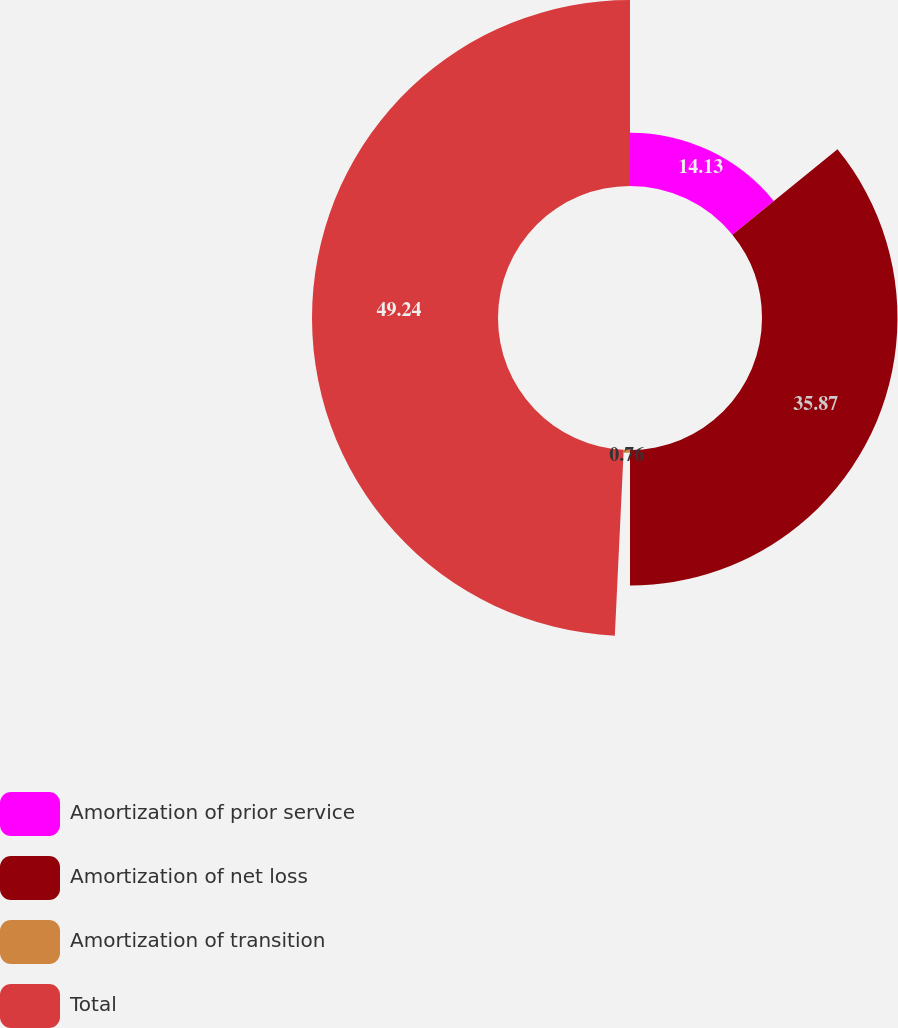Convert chart to OTSL. <chart><loc_0><loc_0><loc_500><loc_500><pie_chart><fcel>Amortization of prior service<fcel>Amortization of net loss<fcel>Amortization of transition<fcel>Total<nl><fcel>14.13%<fcel>35.87%<fcel>0.76%<fcel>49.24%<nl></chart> 